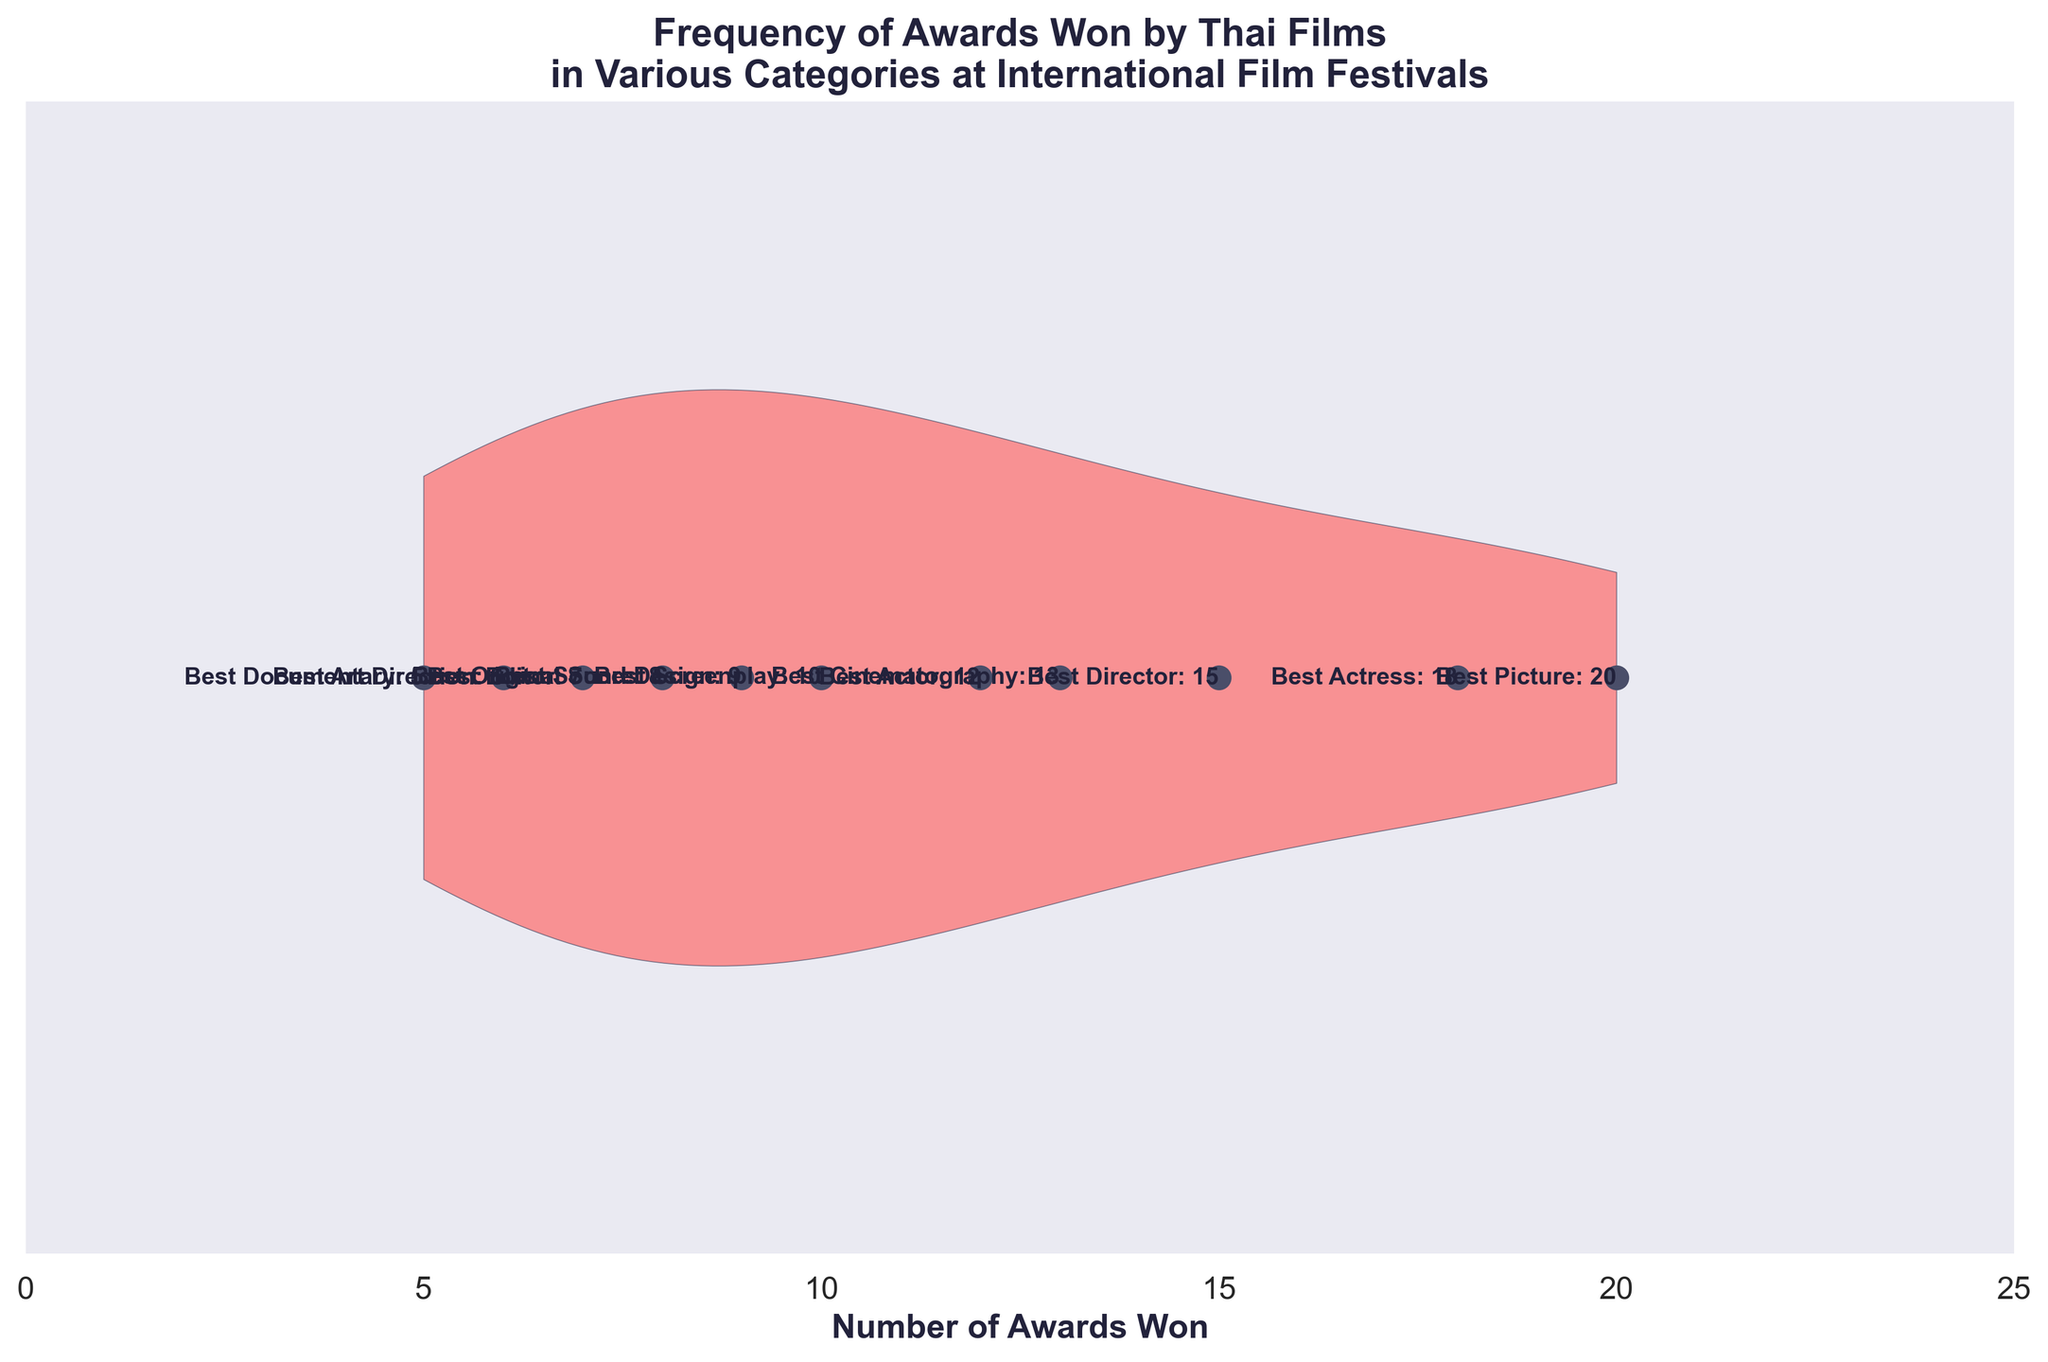What is the title of the chart? The title of the chart is displayed at the top and reads "Frequency of Awards Won by Thai Films in Various Categories at International Film Festivals".
Answer: Frequency of Awards Won by Thai Films in Various Categories at International Film Festivals How many categories are shown in the chart? The chart displays labels for each category alongside the data points scattered on the horizontal axis. Counting the labels gives the total number of categories.
Answer: 11 Which category has won the most awards? To find the category with the most awards, look for the one with the highest number positioned on the horizontal axis.
Answer: Best Picture How many more awards has the Best Actress category won compared to the Best Actor category? Best Actress has 18 awards and Best Actor has 12. To find the difference, subtract the number of awards of Best Actor from Best Actress: 18 - 12 = 6.
Answer: 6 What is the total number of awards won across all categories? Sum all the awards from each category: 20 + 15 + 18 + 12 + 10 + 13 + 7 + 9 + 6 + 8 + 5 = 123.
Answer: 123 Which categories have won less than 10 awards? Look for the data points below the value of 10 on the horizontal axis. These are Best Editor (7), Best Sound Design (9), Best Art Direction (6), Best Original Score (8), and Best Documentary (5).
Answer: Best Editor, Best Sound Design, Best Art Direction, Best Original Score, Best Documentary What is the average number of awards won per category? Calculate the average by dividing the total number of awards by the number of categories: 123 total awards / 11 categories ≈ 11.18.
Answer: 11.18 Which categories have won exactly the same number of awards? Scan for categories that align perfectly at the same position on the horizontal axis, none of the categories have exactly the same number of awards.
Answer: None What is the difference in the number of awards between the category with the most and the least awards? The category with the most is Best Picture (20 awards) and the least is Best Documentary (5 awards). Calculate the difference: 20 - 5 = 15.
Answer: 15 What categories fall closest to the median number of awards won? Arrange the number of awards in ascending order (5, 6, 7, 8, 9, 10, 12, 13, 15, 18, 20), the median is the middle value which is 10 for 11 data points. The category with 10 awards is Best Screenplay.
Answer: Best Screenplay 